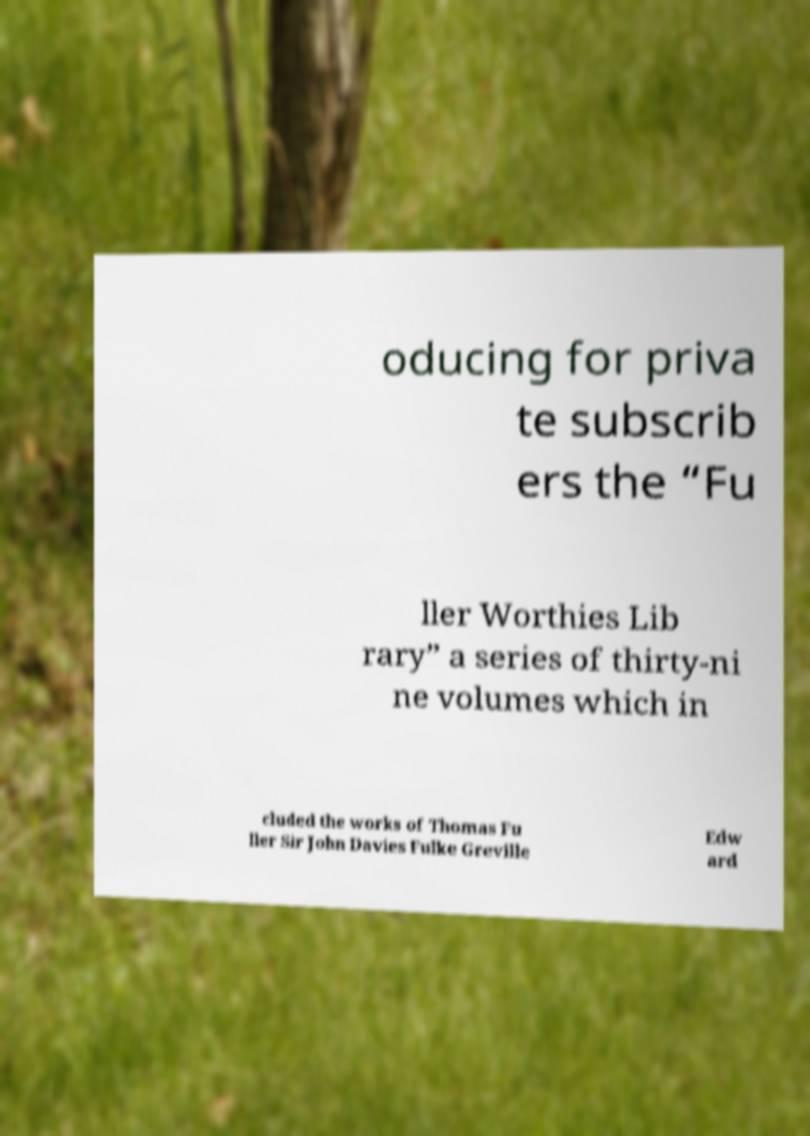Can you read and provide the text displayed in the image?This photo seems to have some interesting text. Can you extract and type it out for me? oducing for priva te subscrib ers the “Fu ller Worthies Lib rary” a series of thirty-ni ne volumes which in cluded the works of Thomas Fu ller Sir John Davies Fulke Greville Edw ard 